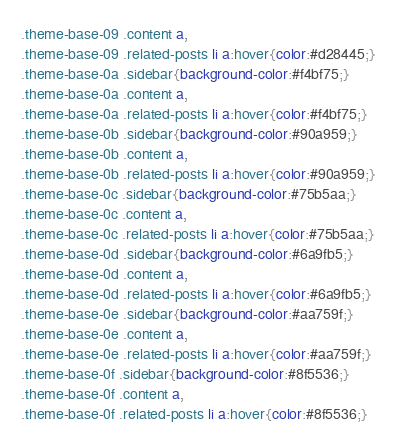Convert code to text. <code><loc_0><loc_0><loc_500><loc_500><_CSS_>.theme-base-09 .content a,
.theme-base-09 .related-posts li a:hover{color:#d28445;}
.theme-base-0a .sidebar{background-color:#f4bf75;}
.theme-base-0a .content a,
.theme-base-0a .related-posts li a:hover{color:#f4bf75;}
.theme-base-0b .sidebar{background-color:#90a959;}
.theme-base-0b .content a,
.theme-base-0b .related-posts li a:hover{color:#90a959;}
.theme-base-0c .sidebar{background-color:#75b5aa;}
.theme-base-0c .content a,
.theme-base-0c .related-posts li a:hover{color:#75b5aa;}
.theme-base-0d .sidebar{background-color:#6a9fb5;}
.theme-base-0d .content a,
.theme-base-0d .related-posts li a:hover{color:#6a9fb5;}
.theme-base-0e .sidebar{background-color:#aa759f;}
.theme-base-0e .content a,
.theme-base-0e .related-posts li a:hover{color:#aa759f;}
.theme-base-0f .sidebar{background-color:#8f5536;}
.theme-base-0f .content a,
.theme-base-0f .related-posts li a:hover{color:#8f5536;}
</code> 